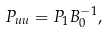Convert formula to latex. <formula><loc_0><loc_0><loc_500><loc_500>P _ { u u } = P _ { 1 } B _ { 0 } ^ { - 1 } ,</formula> 